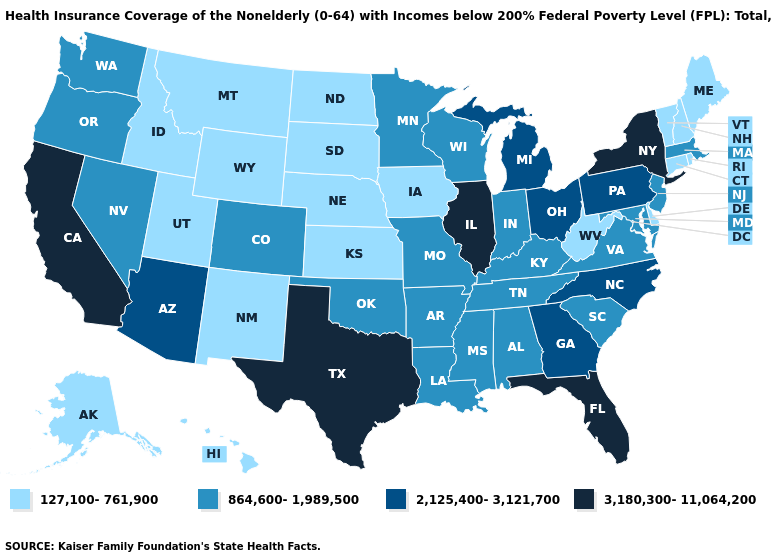Name the states that have a value in the range 864,600-1,989,500?
Be succinct. Alabama, Arkansas, Colorado, Indiana, Kentucky, Louisiana, Maryland, Massachusetts, Minnesota, Mississippi, Missouri, Nevada, New Jersey, Oklahoma, Oregon, South Carolina, Tennessee, Virginia, Washington, Wisconsin. Which states have the lowest value in the West?
Give a very brief answer. Alaska, Hawaii, Idaho, Montana, New Mexico, Utah, Wyoming. Does Pennsylvania have the highest value in the Northeast?
Concise answer only. No. Which states have the lowest value in the USA?
Answer briefly. Alaska, Connecticut, Delaware, Hawaii, Idaho, Iowa, Kansas, Maine, Montana, Nebraska, New Hampshire, New Mexico, North Dakota, Rhode Island, South Dakota, Utah, Vermont, West Virginia, Wyoming. Does Connecticut have the lowest value in the USA?
Concise answer only. Yes. What is the lowest value in states that border Minnesota?
Be succinct. 127,100-761,900. Does the first symbol in the legend represent the smallest category?
Keep it brief. Yes. What is the value of Oklahoma?
Answer briefly. 864,600-1,989,500. Is the legend a continuous bar?
Write a very short answer. No. Name the states that have a value in the range 864,600-1,989,500?
Concise answer only. Alabama, Arkansas, Colorado, Indiana, Kentucky, Louisiana, Maryland, Massachusetts, Minnesota, Mississippi, Missouri, Nevada, New Jersey, Oklahoma, Oregon, South Carolina, Tennessee, Virginia, Washington, Wisconsin. Name the states that have a value in the range 864,600-1,989,500?
Short answer required. Alabama, Arkansas, Colorado, Indiana, Kentucky, Louisiana, Maryland, Massachusetts, Minnesota, Mississippi, Missouri, Nevada, New Jersey, Oklahoma, Oregon, South Carolina, Tennessee, Virginia, Washington, Wisconsin. Does Massachusetts have the lowest value in the Northeast?
Answer briefly. No. Among the states that border Florida , which have the lowest value?
Give a very brief answer. Alabama. What is the value of Alaska?
Give a very brief answer. 127,100-761,900. Does Michigan have a higher value than Illinois?
Keep it brief. No. 